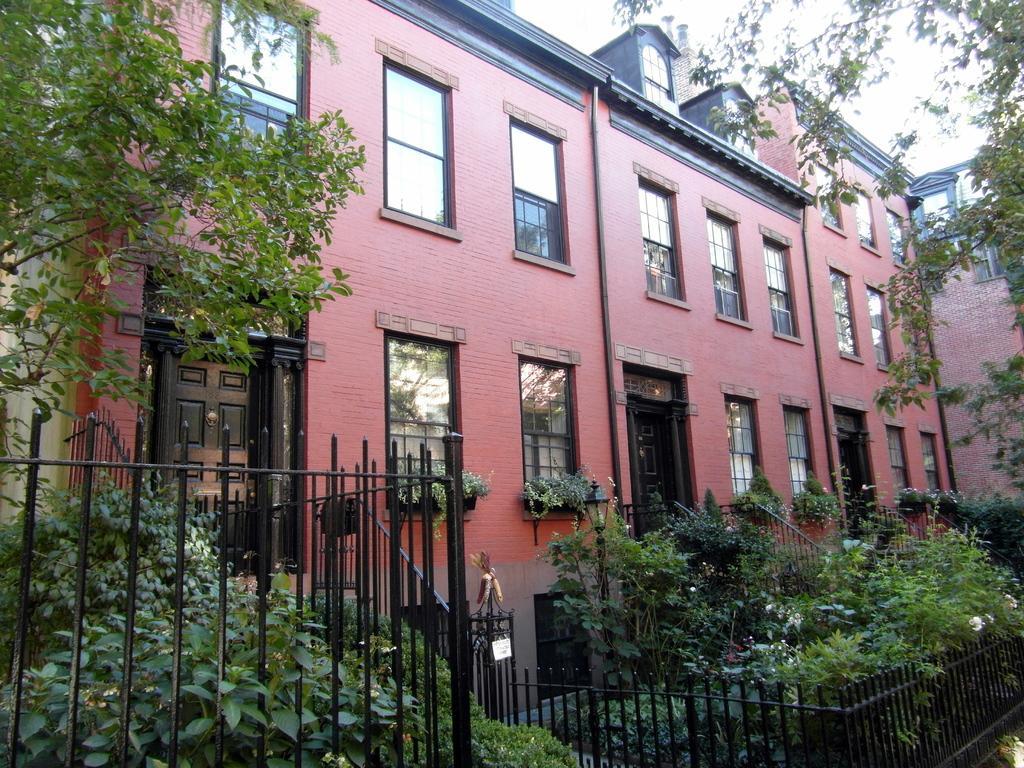How would you summarize this image in a sentence or two? In this image we can see buildings, pipelines, windows, doors, iron grills, plants, trees and sky. 